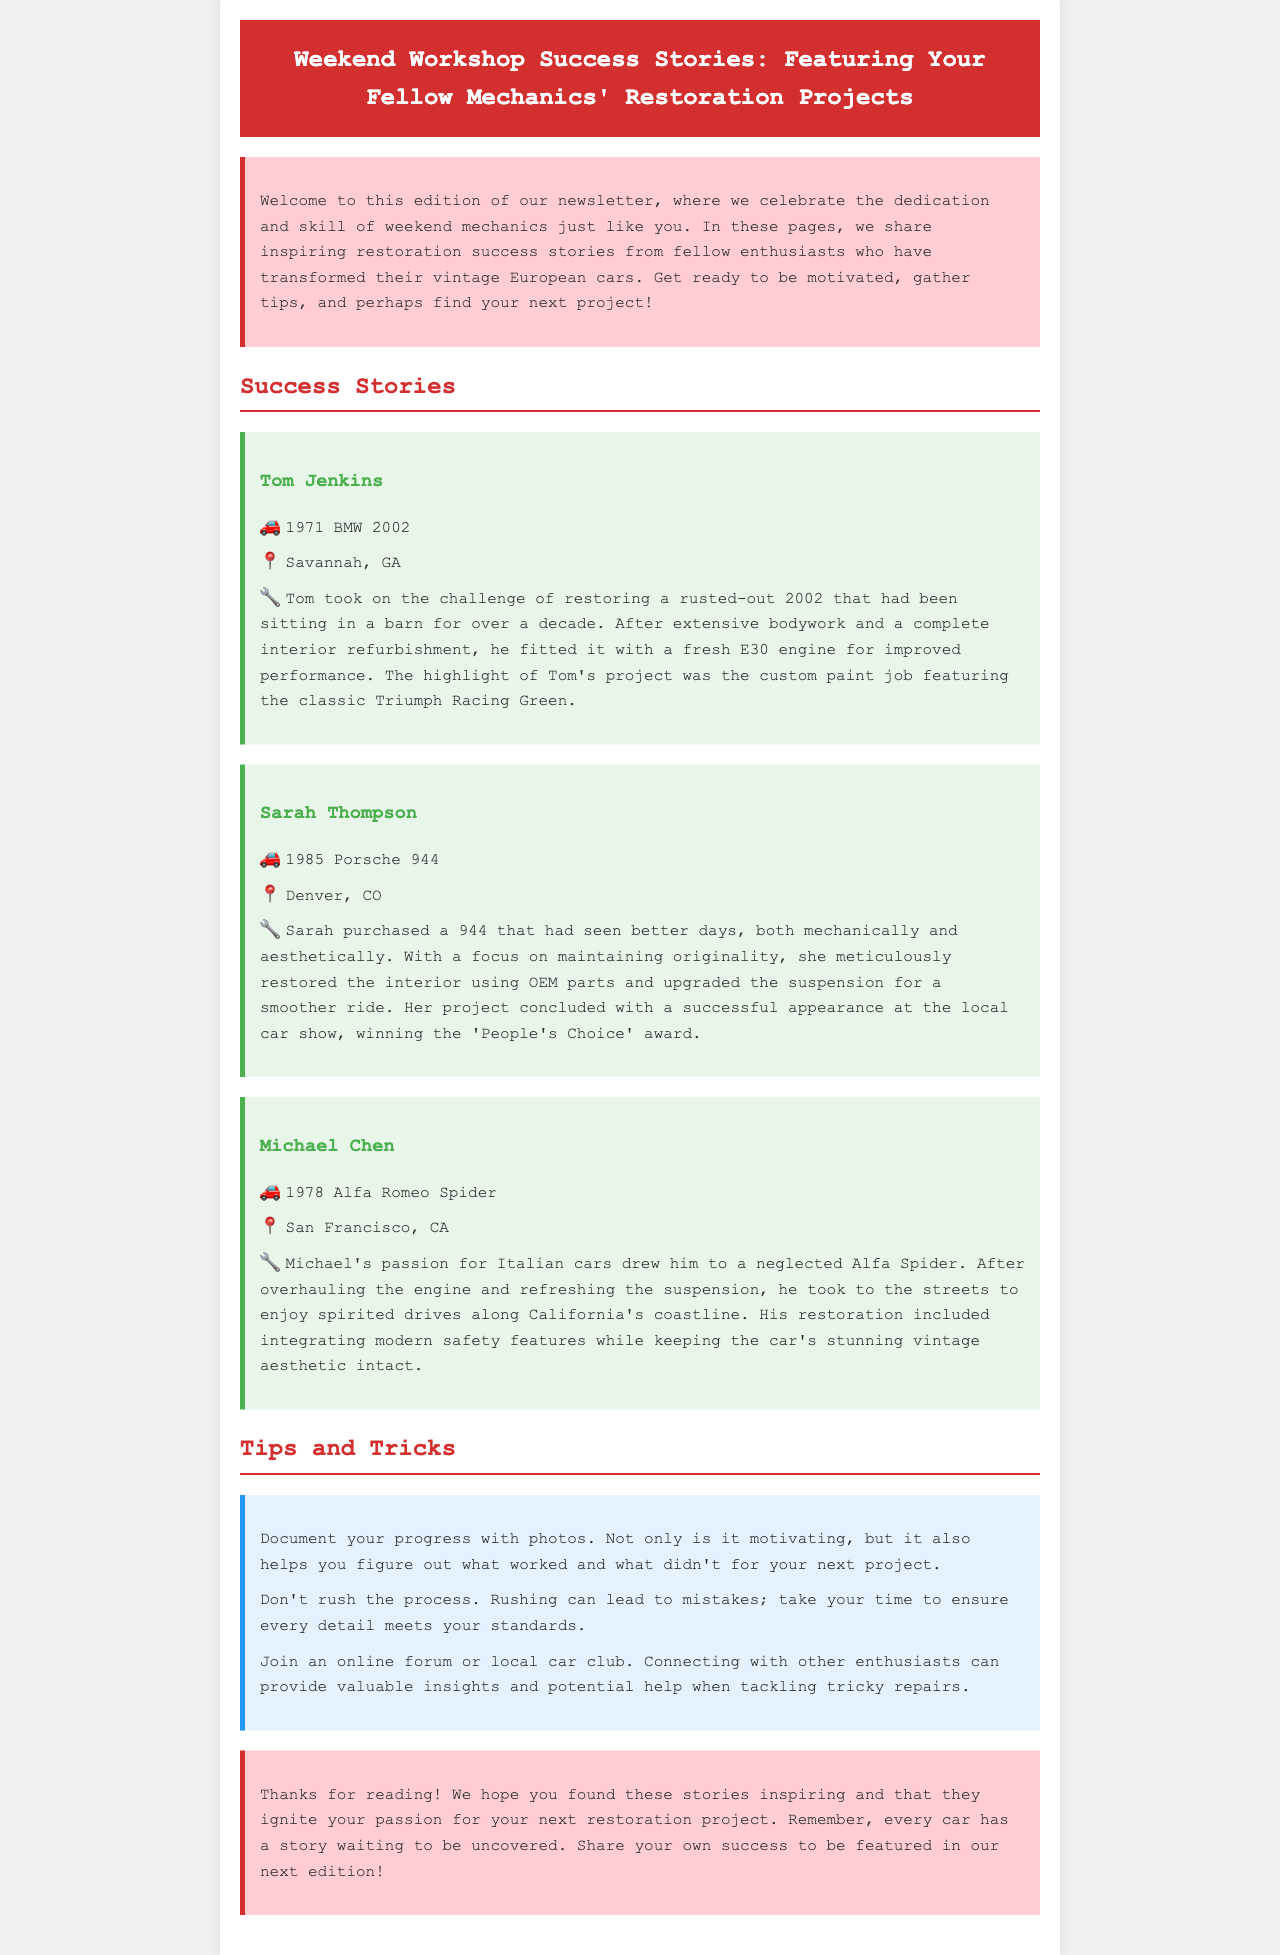What is the title of the newsletter? The title of the newsletter is found in the header section of the document.
Answer: Weekend Workshop Success Stories: Featuring Your Fellow Mechanics' Restoration Projects Who restored a 1985 Porsche 944? The document includes several individuals and their projects, with specific names associated with each car restoration.
Answer: Sarah Thompson What color was the custom paint job on Tom Jenkins' car? The document specifies the color of the paint job in Tom Jenkins' success story.
Answer: Triumph Racing Green Which city is Michael Chen from? The location of each mechanic is mentioned in their respective success stories.
Answer: San Francisco, CA What award did Sarah Thompson win at the car show? The document specifies the recognition Sarah received for her project at a local event, requiring a summary of her achievement.
Answer: People's Choice What year was Tom Jenkins' car? The year of each car is clearly stated alongside the owner's name in the success stories section.
Answer: 1971 What is one tip mentioned for weekend mechanics? The newsletter provides several pieces of advice in a dedicated tips section, focusing on project management.
Answer: Document your progress with photos How many restoration projects are featured in the document? It’s important to account for each success story presented in the newsletter to answer this question accurately.
Answer: Three 